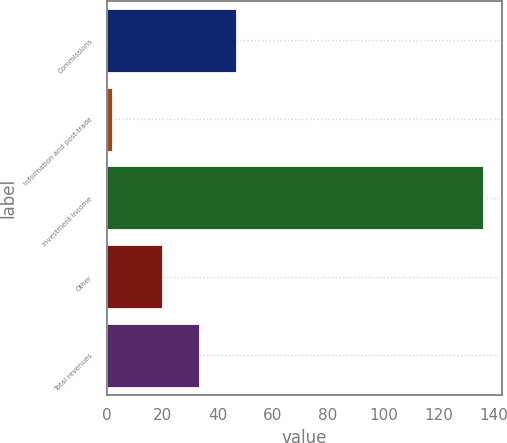<chart> <loc_0><loc_0><loc_500><loc_500><bar_chart><fcel>Commissions<fcel>Information and post-trade<fcel>Investment income<fcel>Other<fcel>Total revenues<nl><fcel>46.86<fcel>1.8<fcel>136.1<fcel>20<fcel>33.43<nl></chart> 